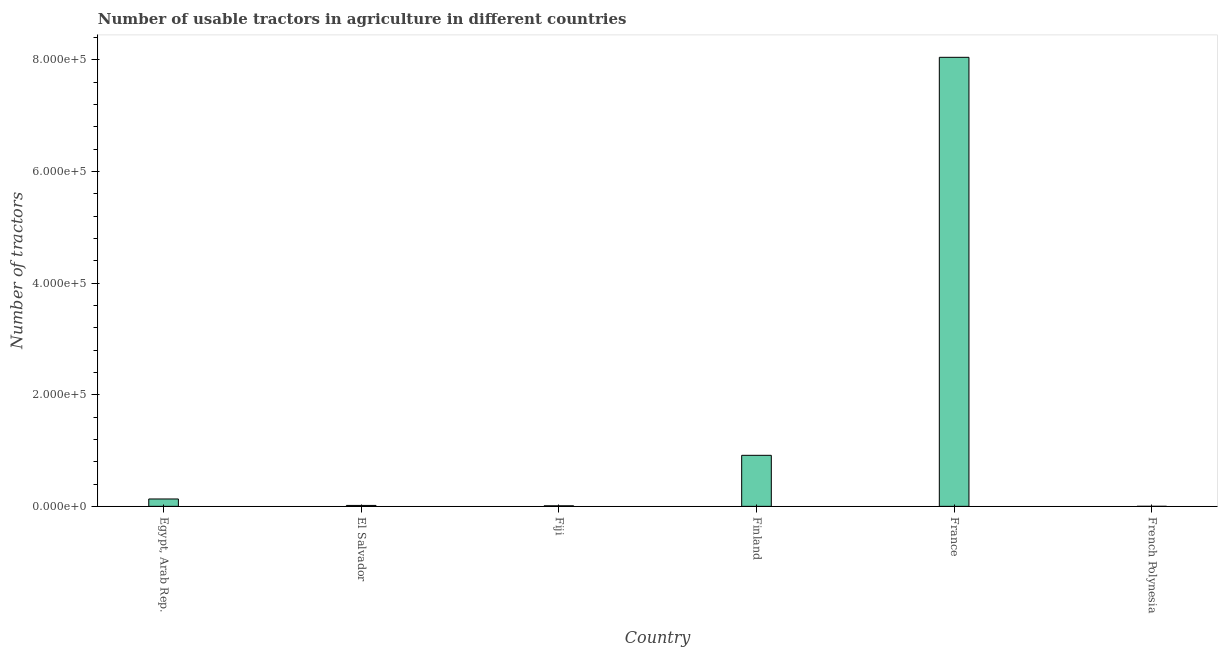Does the graph contain grids?
Provide a succinct answer. No. What is the title of the graph?
Make the answer very short. Number of usable tractors in agriculture in different countries. What is the label or title of the X-axis?
Provide a succinct answer. Country. What is the label or title of the Y-axis?
Offer a terse response. Number of tractors. What is the number of tractors in France?
Make the answer very short. 8.04e+05. Across all countries, what is the maximum number of tractors?
Make the answer very short. 8.04e+05. Across all countries, what is the minimum number of tractors?
Your answer should be very brief. 55. In which country was the number of tractors minimum?
Your answer should be very brief. French Polynesia. What is the sum of the number of tractors?
Ensure brevity in your answer.  9.12e+05. What is the difference between the number of tractors in Egypt, Arab Rep. and El Salvador?
Provide a succinct answer. 1.16e+04. What is the average number of tractors per country?
Ensure brevity in your answer.  1.52e+05. What is the median number of tractors?
Your response must be concise. 7425. What is the ratio of the number of tractors in Egypt, Arab Rep. to that in Fiji?
Offer a very short reply. 13.54. What is the difference between the highest and the second highest number of tractors?
Make the answer very short. 7.13e+05. Is the sum of the number of tractors in Egypt, Arab Rep. and Fiji greater than the maximum number of tractors across all countries?
Your answer should be very brief. No. What is the difference between the highest and the lowest number of tractors?
Offer a very short reply. 8.04e+05. How many bars are there?
Your answer should be compact. 6. How many countries are there in the graph?
Provide a succinct answer. 6. What is the difference between two consecutive major ticks on the Y-axis?
Ensure brevity in your answer.  2.00e+05. What is the Number of tractors of Egypt, Arab Rep.?
Your answer should be compact. 1.32e+04. What is the Number of tractors of El Salvador?
Your answer should be compact. 1650. What is the Number of tractors of Fiji?
Offer a very short reply. 975. What is the Number of tractors in Finland?
Your answer should be compact. 9.14e+04. What is the Number of tractors in France?
Provide a succinct answer. 8.04e+05. What is the difference between the Number of tractors in Egypt, Arab Rep. and El Salvador?
Make the answer very short. 1.16e+04. What is the difference between the Number of tractors in Egypt, Arab Rep. and Fiji?
Provide a succinct answer. 1.22e+04. What is the difference between the Number of tractors in Egypt, Arab Rep. and Finland?
Keep it short and to the point. -7.82e+04. What is the difference between the Number of tractors in Egypt, Arab Rep. and France?
Keep it short and to the point. -7.91e+05. What is the difference between the Number of tractors in Egypt, Arab Rep. and French Polynesia?
Offer a terse response. 1.31e+04. What is the difference between the Number of tractors in El Salvador and Fiji?
Provide a short and direct response. 675. What is the difference between the Number of tractors in El Salvador and Finland?
Give a very brief answer. -8.98e+04. What is the difference between the Number of tractors in El Salvador and France?
Your answer should be very brief. -8.03e+05. What is the difference between the Number of tractors in El Salvador and French Polynesia?
Offer a terse response. 1595. What is the difference between the Number of tractors in Fiji and Finland?
Provide a short and direct response. -9.04e+04. What is the difference between the Number of tractors in Fiji and France?
Provide a short and direct response. -8.03e+05. What is the difference between the Number of tractors in Fiji and French Polynesia?
Make the answer very short. 920. What is the difference between the Number of tractors in Finland and France?
Offer a very short reply. -7.13e+05. What is the difference between the Number of tractors in Finland and French Polynesia?
Your answer should be compact. 9.13e+04. What is the difference between the Number of tractors in France and French Polynesia?
Provide a succinct answer. 8.04e+05. What is the ratio of the Number of tractors in Egypt, Arab Rep. to that in Fiji?
Keep it short and to the point. 13.54. What is the ratio of the Number of tractors in Egypt, Arab Rep. to that in Finland?
Your answer should be very brief. 0.14. What is the ratio of the Number of tractors in Egypt, Arab Rep. to that in France?
Offer a very short reply. 0.02. What is the ratio of the Number of tractors in Egypt, Arab Rep. to that in French Polynesia?
Provide a succinct answer. 240. What is the ratio of the Number of tractors in El Salvador to that in Fiji?
Your response must be concise. 1.69. What is the ratio of the Number of tractors in El Salvador to that in Finland?
Ensure brevity in your answer.  0.02. What is the ratio of the Number of tractors in El Salvador to that in France?
Give a very brief answer. 0. What is the ratio of the Number of tractors in Fiji to that in Finland?
Offer a terse response. 0.01. What is the ratio of the Number of tractors in Fiji to that in French Polynesia?
Keep it short and to the point. 17.73. What is the ratio of the Number of tractors in Finland to that in France?
Offer a very short reply. 0.11. What is the ratio of the Number of tractors in Finland to that in French Polynesia?
Provide a short and direct response. 1661.82. What is the ratio of the Number of tractors in France to that in French Polynesia?
Your answer should be very brief. 1.46e+04. 